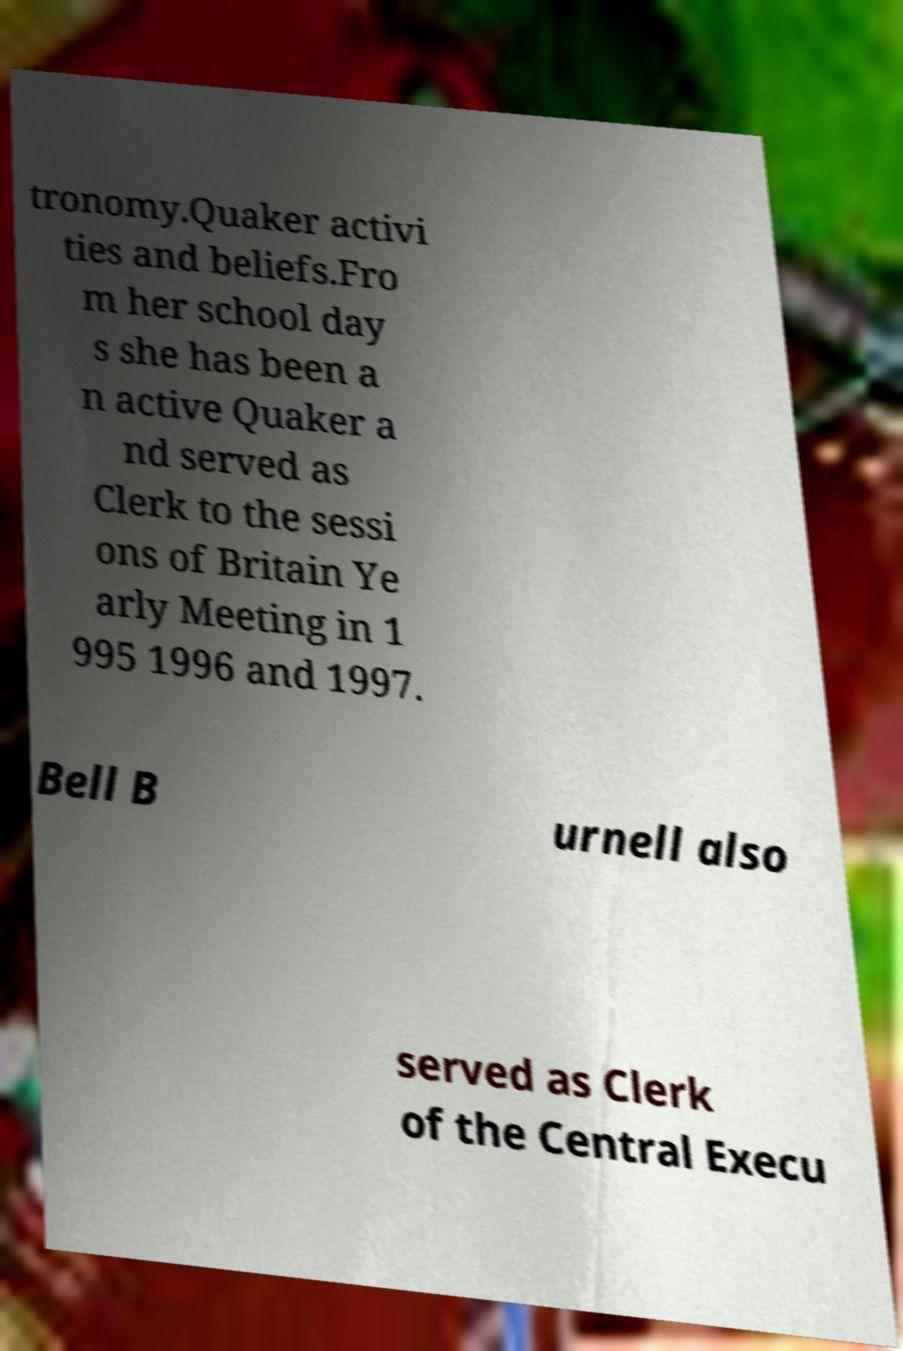Could you assist in decoding the text presented in this image and type it out clearly? tronomy.Quaker activi ties and beliefs.Fro m her school day s she has been a n active Quaker a nd served as Clerk to the sessi ons of Britain Ye arly Meeting in 1 995 1996 and 1997. Bell B urnell also served as Clerk of the Central Execu 